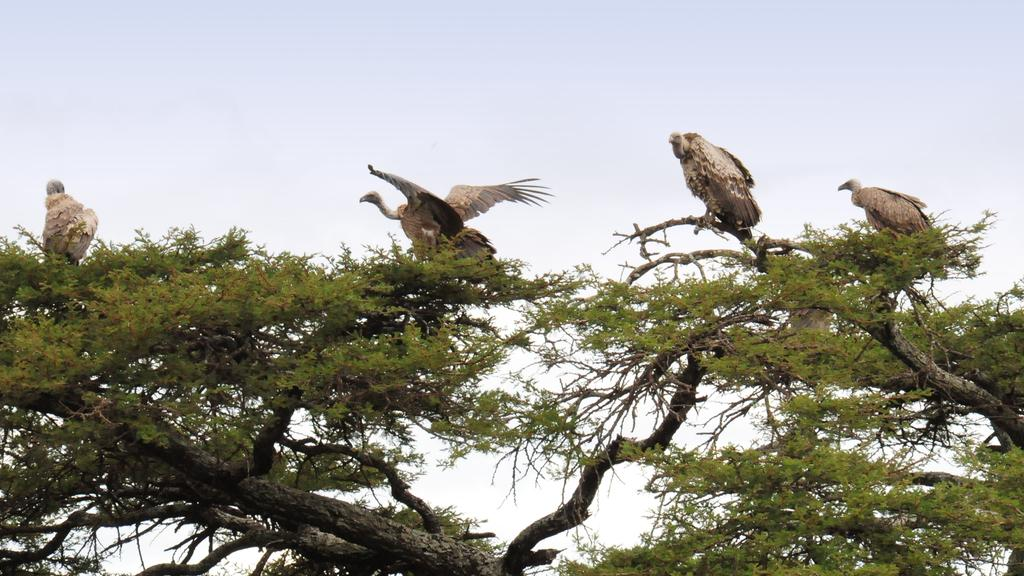How many vultures are in the image? There are four vultures in the image. Where are the vultures located? The vultures are standing on a tree. What can be seen above the tree in the image? The sky is visible above the tree. What type of doctor is standing next to the vultures in the image? There are no doctors present in the image; it only features four vultures standing on a tree. 